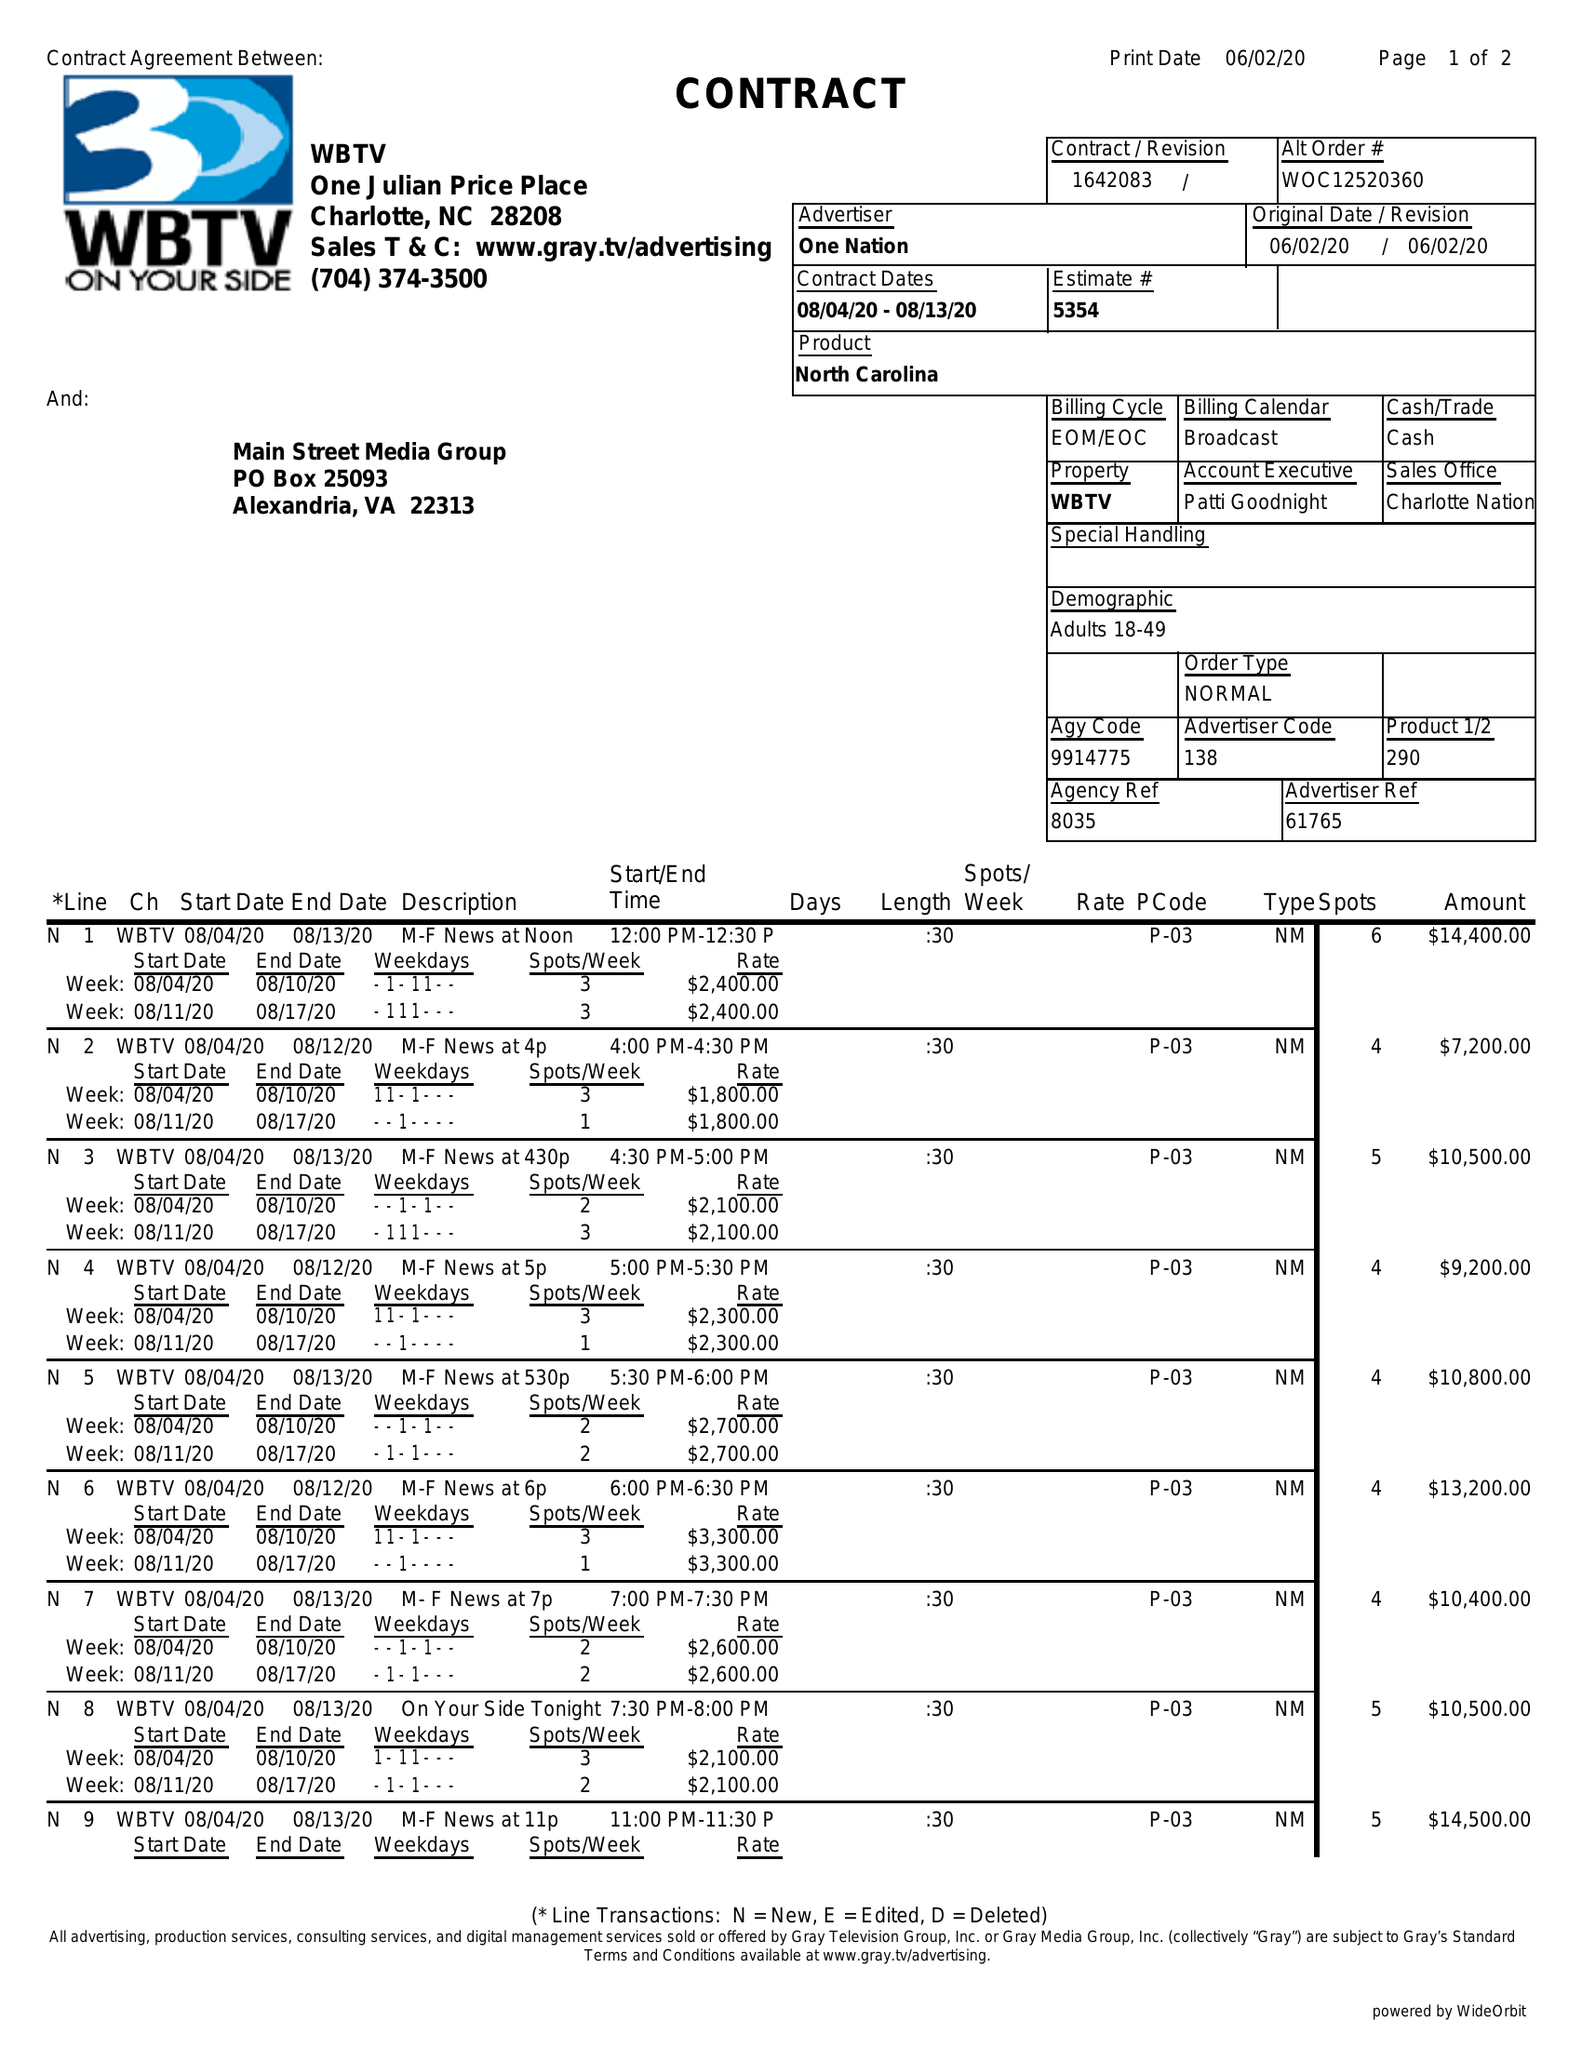What is the value for the advertiser?
Answer the question using a single word or phrase. ONE NATION 